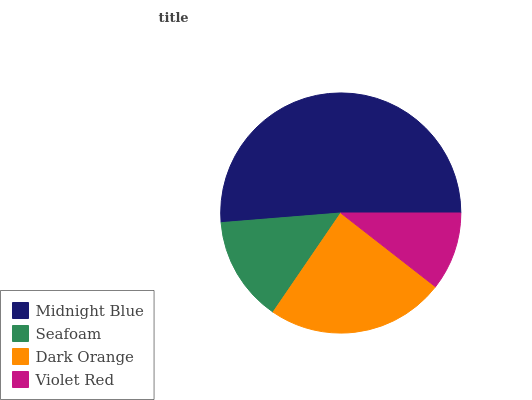Is Violet Red the minimum?
Answer yes or no. Yes. Is Midnight Blue the maximum?
Answer yes or no. Yes. Is Seafoam the minimum?
Answer yes or no. No. Is Seafoam the maximum?
Answer yes or no. No. Is Midnight Blue greater than Seafoam?
Answer yes or no. Yes. Is Seafoam less than Midnight Blue?
Answer yes or no. Yes. Is Seafoam greater than Midnight Blue?
Answer yes or no. No. Is Midnight Blue less than Seafoam?
Answer yes or no. No. Is Dark Orange the high median?
Answer yes or no. Yes. Is Seafoam the low median?
Answer yes or no. Yes. Is Seafoam the high median?
Answer yes or no. No. Is Midnight Blue the low median?
Answer yes or no. No. 